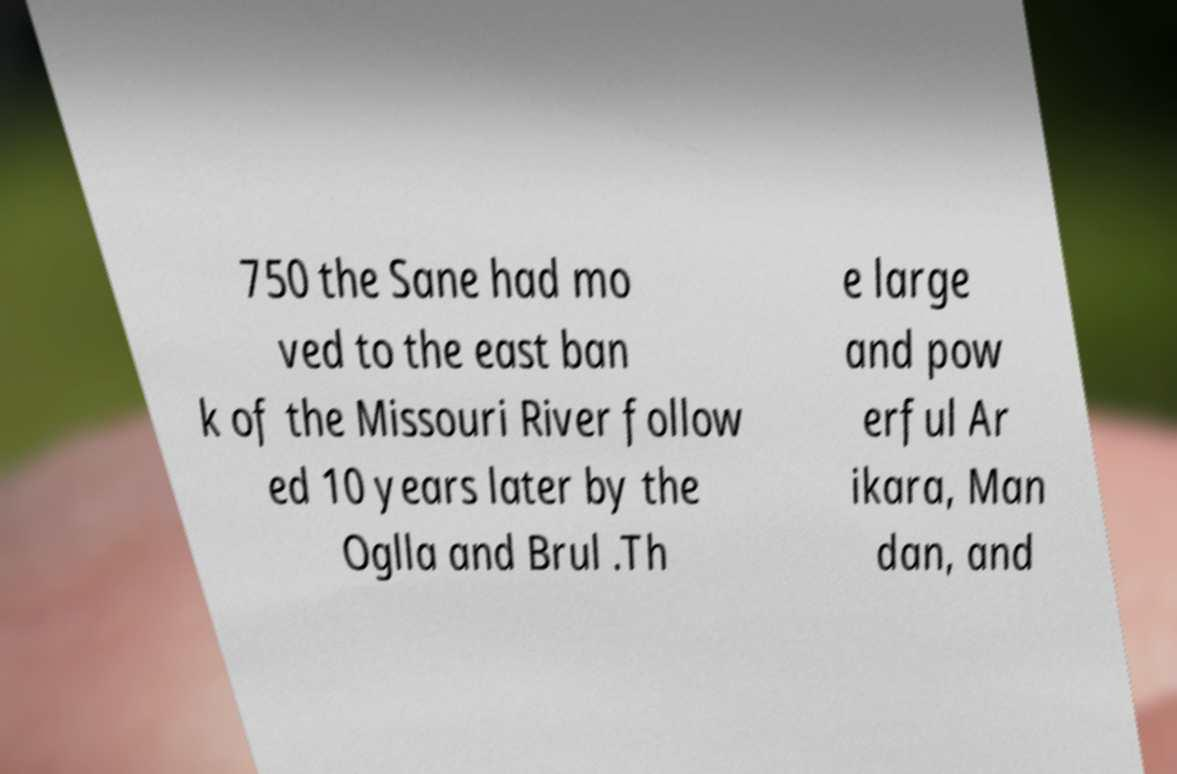For documentation purposes, I need the text within this image transcribed. Could you provide that? 750 the Sane had mo ved to the east ban k of the Missouri River follow ed 10 years later by the Oglla and Brul .Th e large and pow erful Ar ikara, Man dan, and 